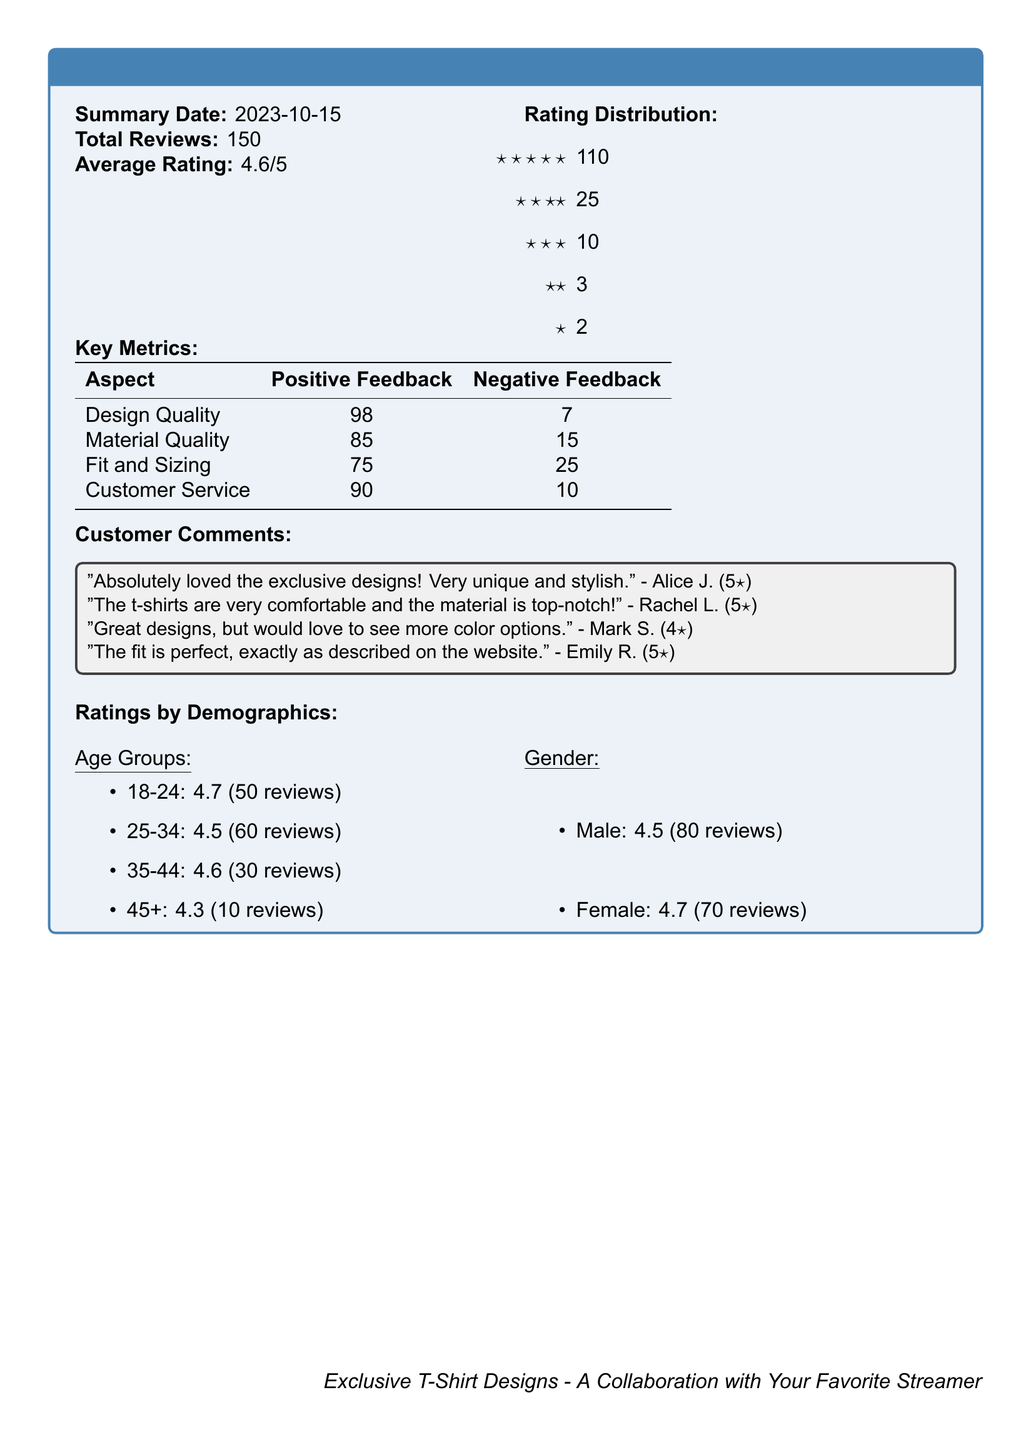What is the summary date? The summary date is the date when the customer feedback was aggregated, which is mentioned at the beginning of the document.
Answer: 2023-10-15 What is the average rating? The average rating is calculated from the total reviews provided in the document, reflecting overall customer satisfaction.
Answer: 4.6/5 How many total reviews were received? The total number of reviews indicates how many customers provided feedback regarding the exclusive t-shirt designs.
Answer: 150 What is the positive feedback count for design quality? The positive feedback count provides insight into how customers feel about the design quality of the t-shirts, indicating a strong reception.
Answer: 98 Which age group has the highest rating? This question looks for the age group with the best average rating, indicating preferences among different customer demographics.
Answer: 18-24 What feedback was given regarding the material quality? The feedback count for material quality shows how many customers had positive versus negative feedback on this aspect of the t-shirts.
Answer: 85 What do customers want more of according to comments? The customer comment highlights a specific request from a buyer that suggests a potential area for product improvement.
Answer: More color options What was the negative feedback count for fit and sizing? This number indicates how many customers expressed dissatisfaction with the fit and sizing of the t-shirts, essential for understanding fit issues.
Answer: 25 What gender group rated the t-shirts higher? The gender rating comparison indicates which group found the product more favorable and can help target marketing strategies.
Answer: Female 